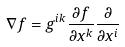<formula> <loc_0><loc_0><loc_500><loc_500>\nabla f = g ^ { i k } \frac { \partial f } { \partial x ^ { k } } \frac { \partial } { \partial x ^ { i } }</formula> 